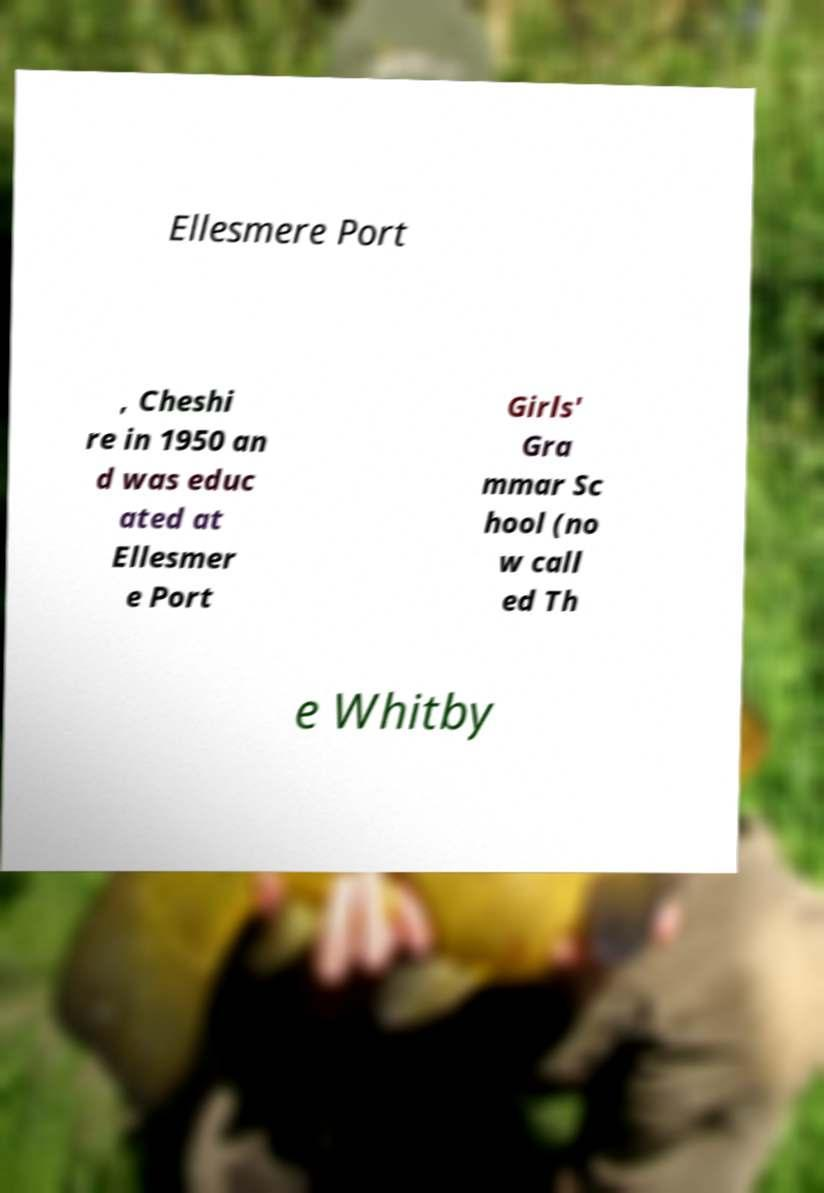What messages or text are displayed in this image? I need them in a readable, typed format. Ellesmere Port , Cheshi re in 1950 an d was educ ated at Ellesmer e Port Girls' Gra mmar Sc hool (no w call ed Th e Whitby 